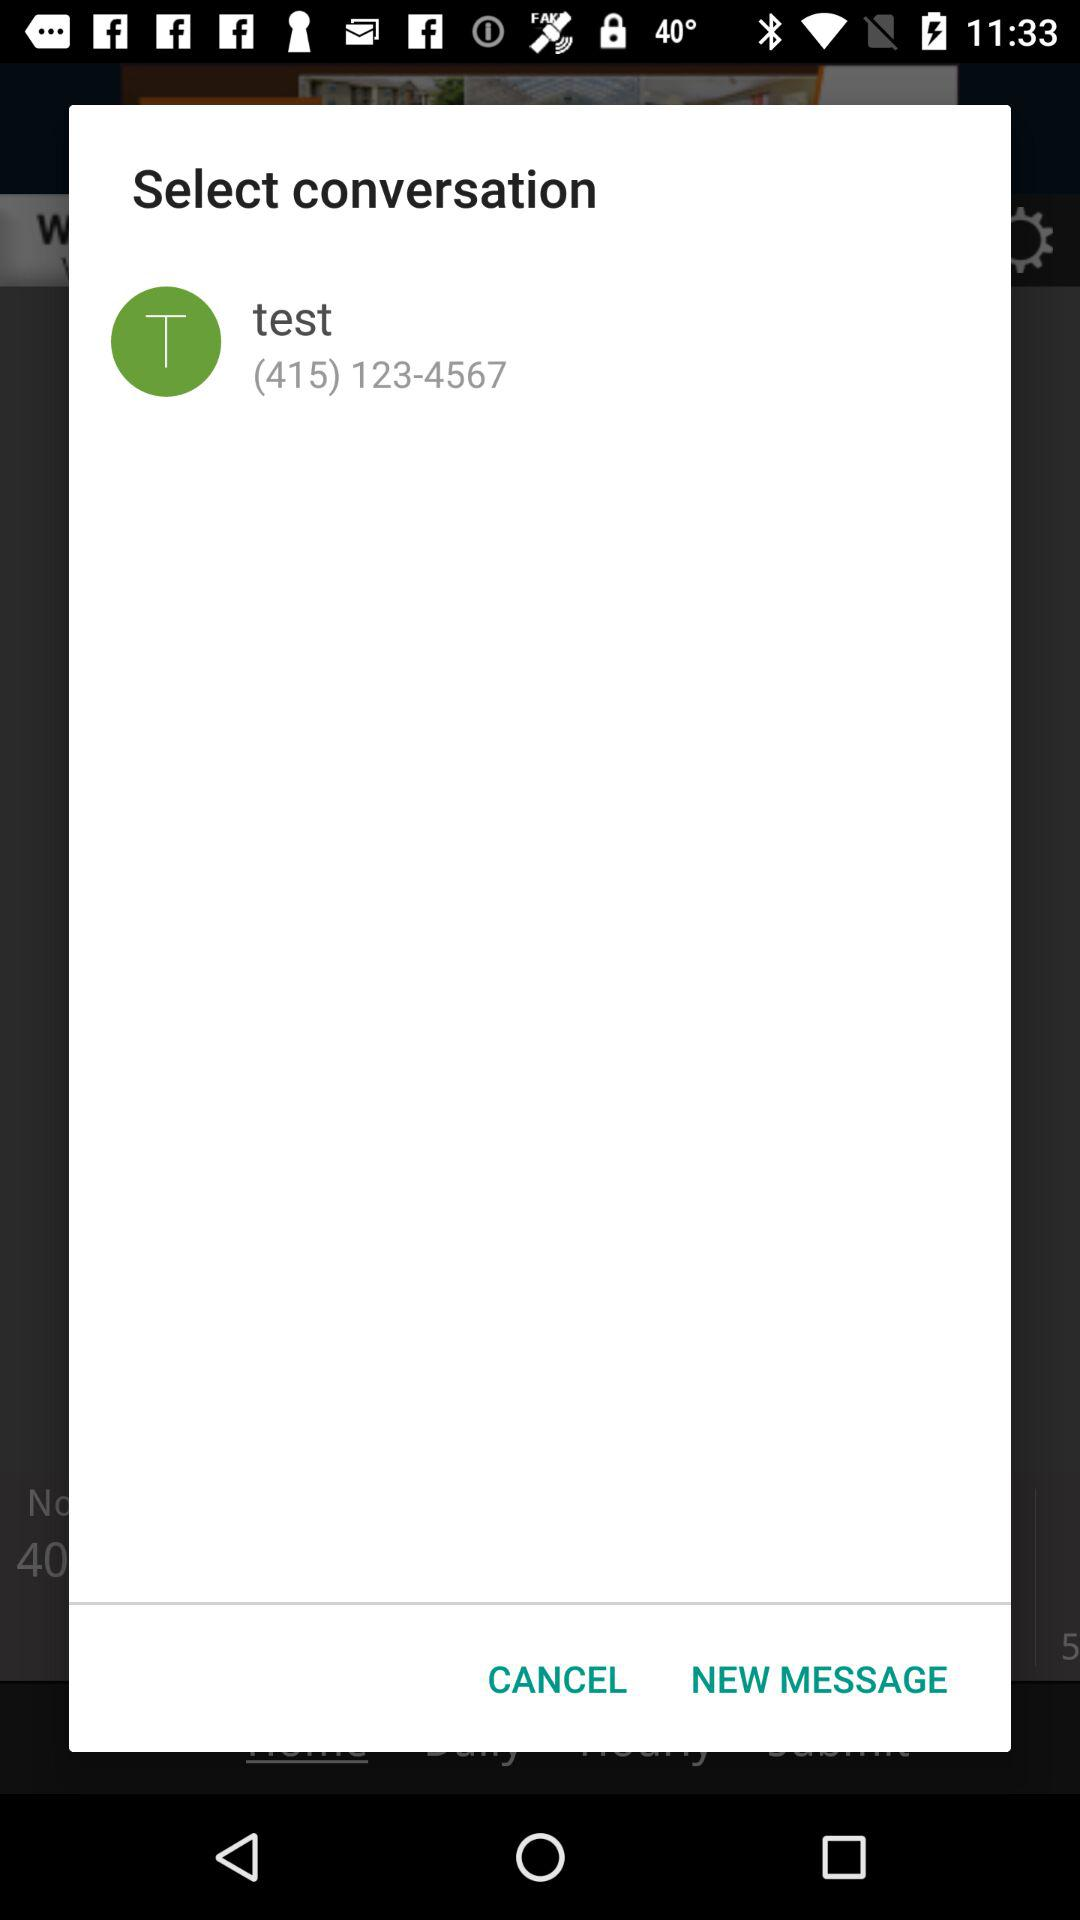What is the "test" phone number? The phone number is (415) 123-4567. 